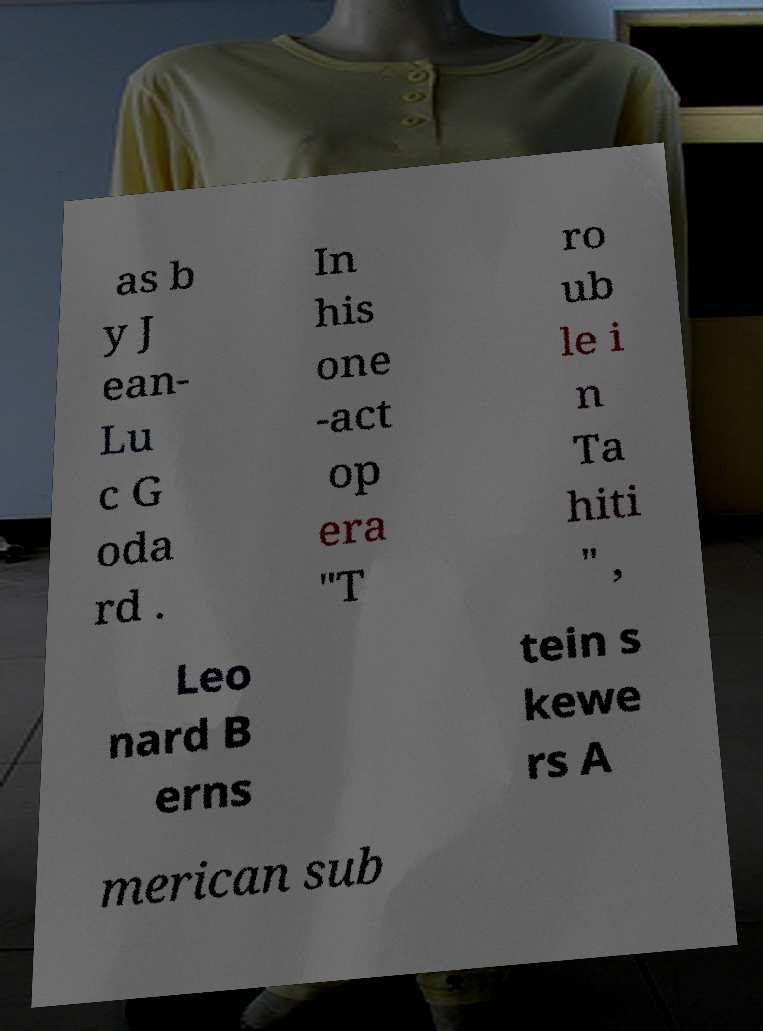Please identify and transcribe the text found in this image. as b y J ean- Lu c G oda rd . In his one -act op era "T ro ub le i n Ta hiti " , Leo nard B erns tein s kewe rs A merican sub 